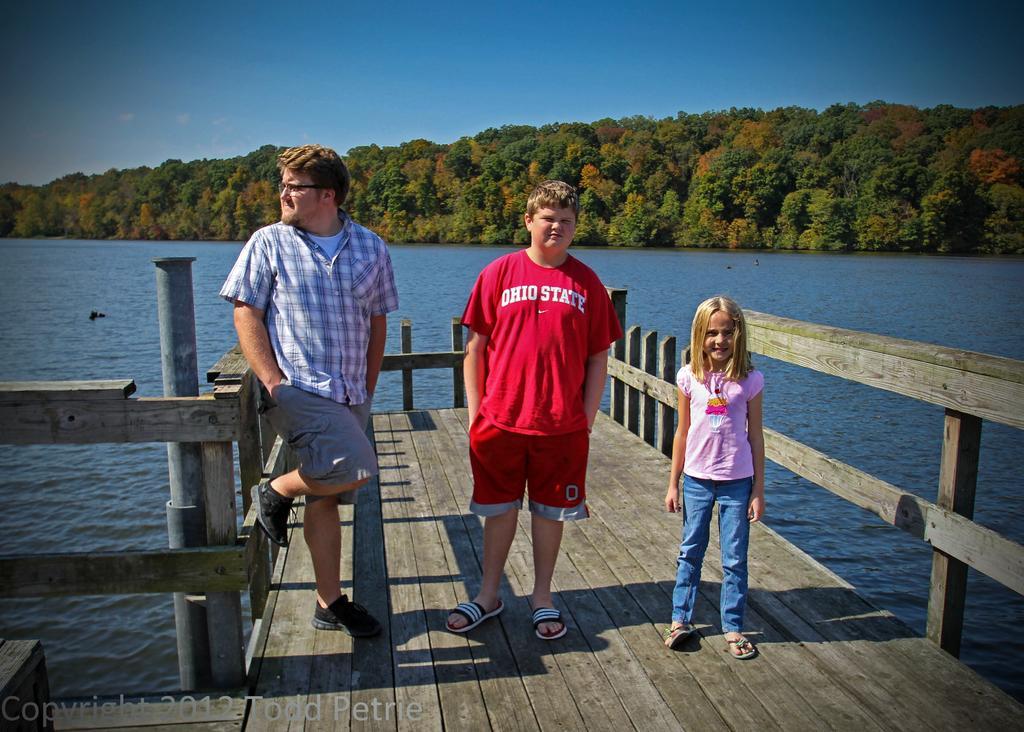Can you describe this image briefly? In this image we can see standing on the walkway bridge. In the background we can see water, trees and sky. 